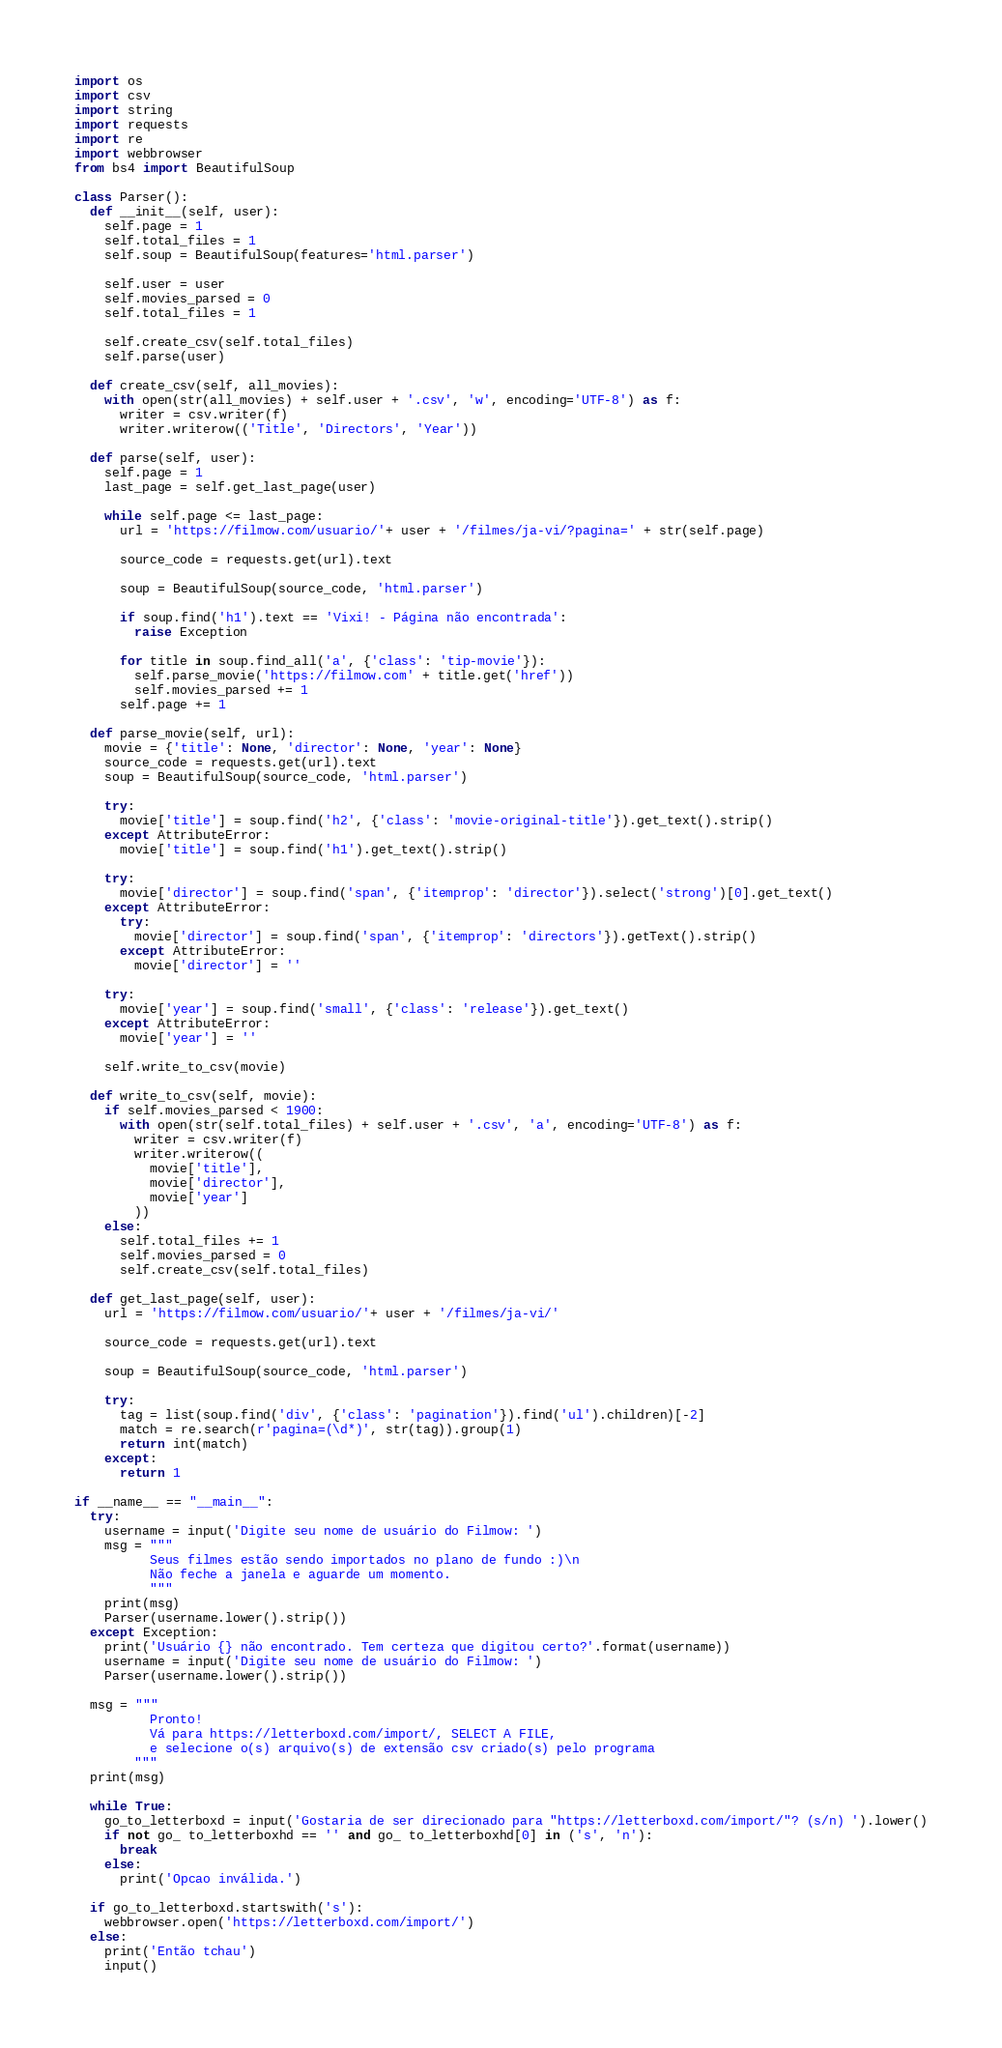<code> <loc_0><loc_0><loc_500><loc_500><_Python_>import os
import csv
import string
import requests
import re
import webbrowser
from bs4 import BeautifulSoup

class Parser():
  def __init__(self, user):
    self.page = 1
    self.total_files = 1
    self.soup = BeautifulSoup(features='html.parser')

    self.user = user
    self.movies_parsed = 0
    self.total_files = 1

    self.create_csv(self.total_files)
    self.parse(user)
    
  def create_csv(self, all_movies):
    with open(str(all_movies) + self.user + '.csv', 'w', encoding='UTF-8') as f:
      writer = csv.writer(f)
      writer.writerow(('Title', 'Directors', 'Year'))
  
  def parse(self, user):
    self.page = 1
    last_page = self.get_last_page(user)

    while self.page <= last_page:
      url = 'https://filmow.com/usuario/'+ user + '/filmes/ja-vi/?pagina=' + str(self.page)

      source_code = requests.get(url).text

      soup = BeautifulSoup(source_code, 'html.parser')

      if soup.find('h1').text == 'Vixi! - Página não encontrada':
        raise Exception

      for title in soup.find_all('a', {'class': 'tip-movie'}):
        self.parse_movie('https://filmow.com' + title.get('href'))
        self.movies_parsed += 1
      self.page += 1

  def parse_movie(self, url):
    movie = {'title': None, 'director': None, 'year': None}
    source_code = requests.get(url).text
    soup = BeautifulSoup(source_code, 'html.parser')

    try:
      movie['title'] = soup.find('h2', {'class': 'movie-original-title'}).get_text().strip()
    except AttributeError:
      movie['title'] = soup.find('h1').get_text().strip()

    try:
      movie['director'] = soup.find('span', {'itemprop': 'director'}).select('strong')[0].get_text()
    except AttributeError:
      try:
        movie['director'] = soup.find('span', {'itemprop': 'directors'}).getText().strip()
      except AttributeError:
        movie['director'] = ''

    try:
      movie['year'] = soup.find('small', {'class': 'release'}).get_text()
    except AttributeError:
      movie['year'] = ''

    self.write_to_csv(movie)

  def write_to_csv(self, movie):
    if self.movies_parsed < 1900:
      with open(str(self.total_files) + self.user + '.csv', 'a', encoding='UTF-8') as f:
        writer = csv.writer(f)
        writer.writerow((
          movie['title'],
          movie['director'],
          movie['year']
        ))
    else:
      self.total_files += 1
      self.movies_parsed = 0
      self.create_csv(self.total_files)
      
  def get_last_page(self, user):
    url = 'https://filmow.com/usuario/'+ user + '/filmes/ja-vi/'

    source_code = requests.get(url).text

    soup = BeautifulSoup(source_code, 'html.parser')

    try:
      tag = list(soup.find('div', {'class': 'pagination'}).find('ul').children)[-2]
      match = re.search(r'pagina=(\d*)', str(tag)).group(1)
      return int(match)
    except:
      return 1

if __name__ == "__main__":
  try:
    username = input('Digite seu nome de usuário do Filmow: ')
    msg = """
          Seus filmes estão sendo importados no plano de fundo :)\n
          Não feche a janela e aguarde um momento.
          """
    print(msg)
    Parser(username.lower().strip())
  except Exception:
    print('Usuário {} não encontrado. Tem certeza que digitou certo?'.format(username))
    username = input('Digite seu nome de usuário do Filmow: ')
    Parser(username.lower().strip())

  msg = """
          Pronto!
          Vá para https://letterboxd.com/import/, SELECT A FILE, 
          e selecione o(s) arquivo(s) de extensão csv criado(s) pelo programa
        """
  print(msg)

  while True:
    go_to_letterboxd = input('Gostaria de ser direcionado para "https://letterboxd.com/import/"? (s/n) ').lower()
    if not go_ to_letterboxhd == '' and go_ to_letterboxhd[0] in ('s', 'n'):
      break
    else:
      print('Opcao inválida.')

  if go_to_letterboxd.startswith('s'):
    webbrowser.open('https://letterboxd.com/import/')
  else:
    print('Então tchau')
    input()
</code> 